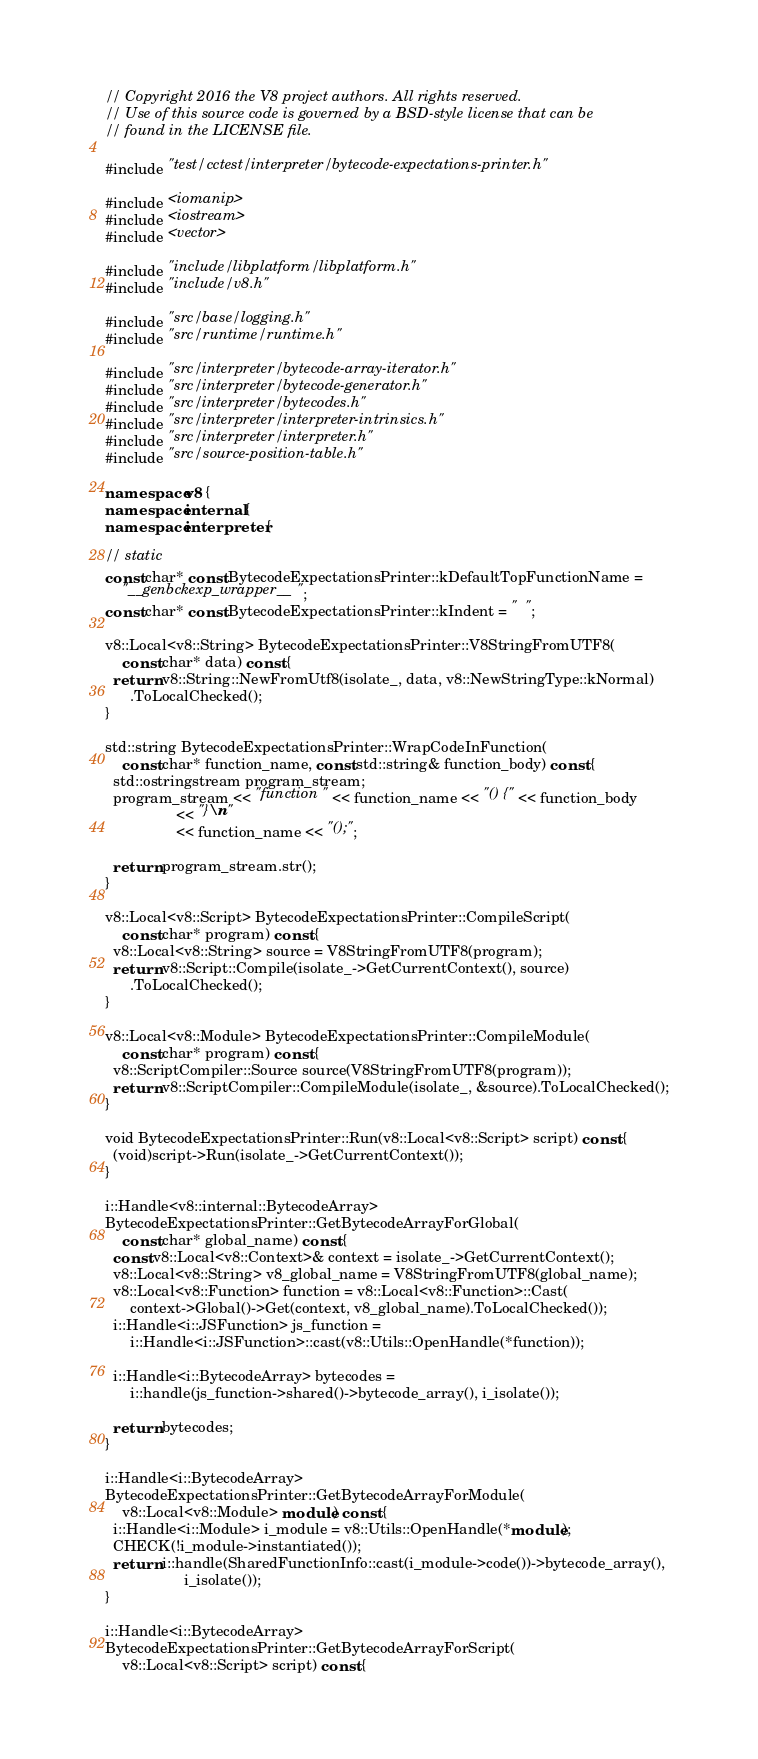Convert code to text. <code><loc_0><loc_0><loc_500><loc_500><_C++_>// Copyright 2016 the V8 project authors. All rights reserved.
// Use of this source code is governed by a BSD-style license that can be
// found in the LICENSE file.

#include "test/cctest/interpreter/bytecode-expectations-printer.h"

#include <iomanip>
#include <iostream>
#include <vector>

#include "include/libplatform/libplatform.h"
#include "include/v8.h"

#include "src/base/logging.h"
#include "src/runtime/runtime.h"

#include "src/interpreter/bytecode-array-iterator.h"
#include "src/interpreter/bytecode-generator.h"
#include "src/interpreter/bytecodes.h"
#include "src/interpreter/interpreter-intrinsics.h"
#include "src/interpreter/interpreter.h"
#include "src/source-position-table.h"

namespace v8 {
namespace internal {
namespace interpreter {

// static
const char* const BytecodeExpectationsPrinter::kDefaultTopFunctionName =
    "__genbckexp_wrapper__";
const char* const BytecodeExpectationsPrinter::kIndent = "  ";

v8::Local<v8::String> BytecodeExpectationsPrinter::V8StringFromUTF8(
    const char* data) const {
  return v8::String::NewFromUtf8(isolate_, data, v8::NewStringType::kNormal)
      .ToLocalChecked();
}

std::string BytecodeExpectationsPrinter::WrapCodeInFunction(
    const char* function_name, const std::string& function_body) const {
  std::ostringstream program_stream;
  program_stream << "function " << function_name << "() {" << function_body
                 << "}\n"
                 << function_name << "();";

  return program_stream.str();
}

v8::Local<v8::Script> BytecodeExpectationsPrinter::CompileScript(
    const char* program) const {
  v8::Local<v8::String> source = V8StringFromUTF8(program);
  return v8::Script::Compile(isolate_->GetCurrentContext(), source)
      .ToLocalChecked();
}

v8::Local<v8::Module> BytecodeExpectationsPrinter::CompileModule(
    const char* program) const {
  v8::ScriptCompiler::Source source(V8StringFromUTF8(program));
  return v8::ScriptCompiler::CompileModule(isolate_, &source).ToLocalChecked();
}

void BytecodeExpectationsPrinter::Run(v8::Local<v8::Script> script) const {
  (void)script->Run(isolate_->GetCurrentContext());
}

i::Handle<v8::internal::BytecodeArray>
BytecodeExpectationsPrinter::GetBytecodeArrayForGlobal(
    const char* global_name) const {
  const v8::Local<v8::Context>& context = isolate_->GetCurrentContext();
  v8::Local<v8::String> v8_global_name = V8StringFromUTF8(global_name);
  v8::Local<v8::Function> function = v8::Local<v8::Function>::Cast(
      context->Global()->Get(context, v8_global_name).ToLocalChecked());
  i::Handle<i::JSFunction> js_function =
      i::Handle<i::JSFunction>::cast(v8::Utils::OpenHandle(*function));

  i::Handle<i::BytecodeArray> bytecodes =
      i::handle(js_function->shared()->bytecode_array(), i_isolate());

  return bytecodes;
}

i::Handle<i::BytecodeArray>
BytecodeExpectationsPrinter::GetBytecodeArrayForModule(
    v8::Local<v8::Module> module) const {
  i::Handle<i::Module> i_module = v8::Utils::OpenHandle(*module);
  CHECK(!i_module->instantiated());
  return i::handle(SharedFunctionInfo::cast(i_module->code())->bytecode_array(),
                   i_isolate());
}

i::Handle<i::BytecodeArray>
BytecodeExpectationsPrinter::GetBytecodeArrayForScript(
    v8::Local<v8::Script> script) const {</code> 